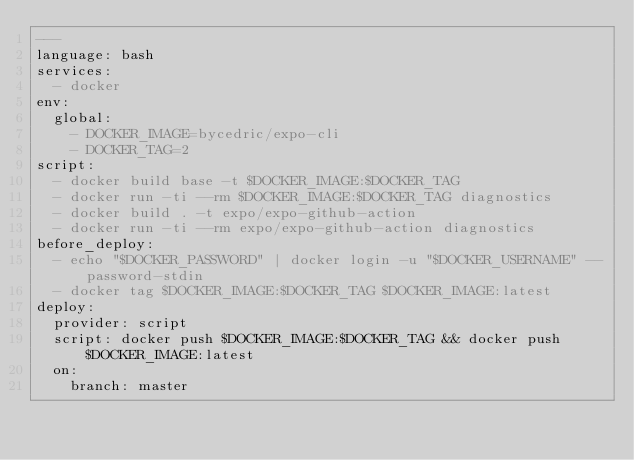<code> <loc_0><loc_0><loc_500><loc_500><_YAML_>---
language: bash
services:
  - docker
env:
  global:
    - DOCKER_IMAGE=bycedric/expo-cli
    - DOCKER_TAG=2
script:
  - docker build base -t $DOCKER_IMAGE:$DOCKER_TAG
  - docker run -ti --rm $DOCKER_IMAGE:$DOCKER_TAG diagnostics
  - docker build . -t expo/expo-github-action
  - docker run -ti --rm expo/expo-github-action diagnostics
before_deploy:
  - echo "$DOCKER_PASSWORD" | docker login -u "$DOCKER_USERNAME" --password-stdin
  - docker tag $DOCKER_IMAGE:$DOCKER_TAG $DOCKER_IMAGE:latest
deploy:
  provider: script
  script: docker push $DOCKER_IMAGE:$DOCKER_TAG && docker push $DOCKER_IMAGE:latest
  on:
    branch: master
</code> 